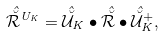<formula> <loc_0><loc_0><loc_500><loc_500>\hat { \breve { \mathcal { R } } } ^ { U _ { K } } = \hat { \breve { \mathcal { U } } } _ { K } \bullet \hat { \breve { \mathcal { R } } } \bullet \hat { \breve { \mathcal { U } } } _ { K } ^ { + } ,</formula> 